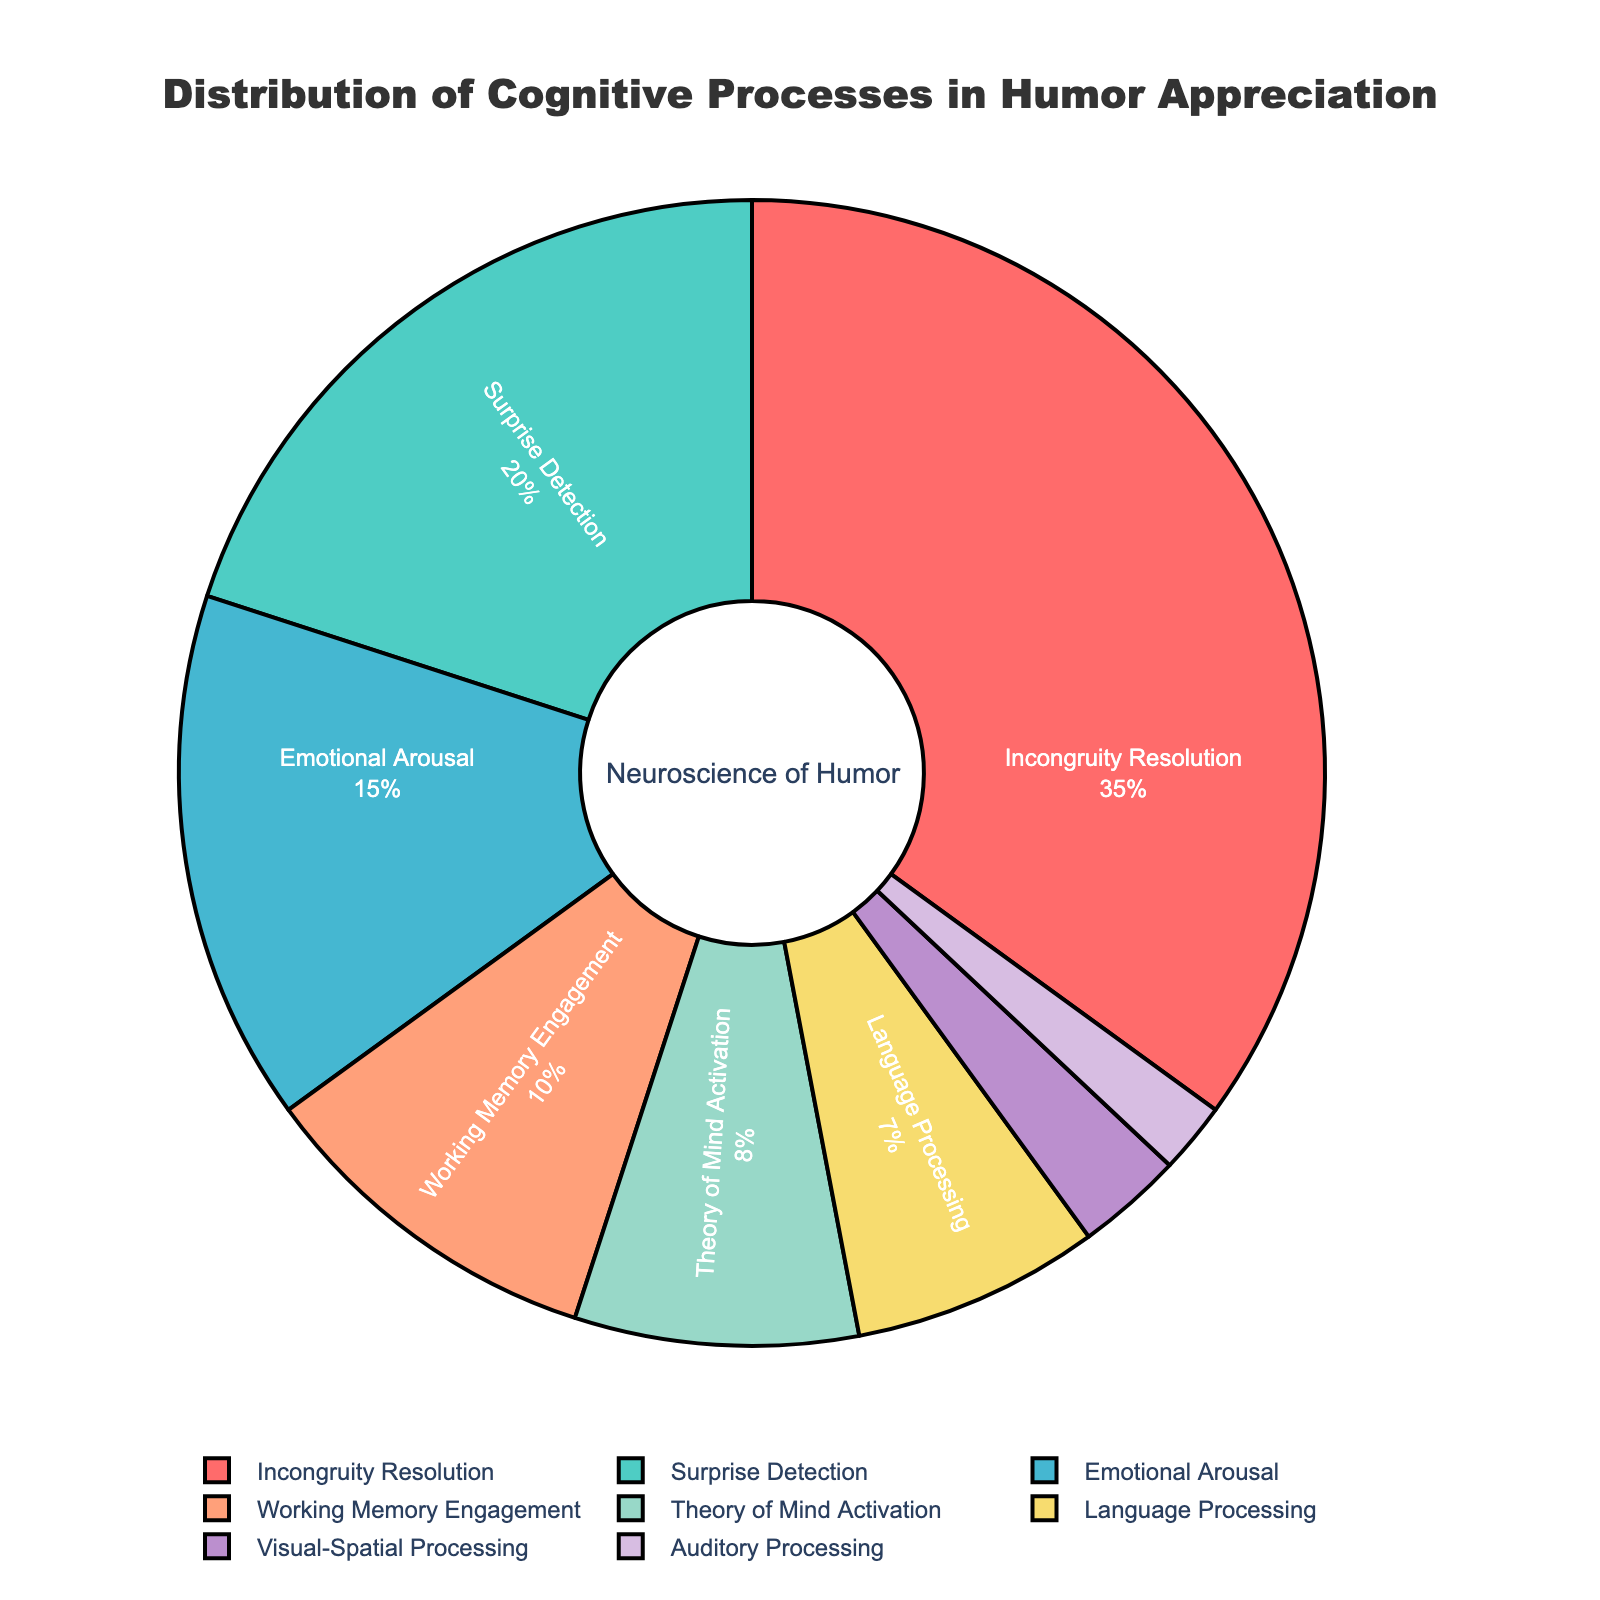What's the most prominent cognitive process involved in humor appreciation and its percentage? The figure indicates the cognitive processes and their corresponding percentages in humor appreciation. "Incongruity Resolution" has the largest slice associated with it.
Answer: Incongruity Resolution, 35% Which cognitive process has the smallest contribution and its percentage? The figure displays all cognitive processes and their percentages. "Auditory Processing" has the smallest contribution.
Answer: Auditory Processing, 2% What is the combined percentage of Theory of Mind Activation and Language Processing? The figure shows individual percentages for each cognitive process. Adding the percentages of "Theory of Mind Activation" (8%) and "Language Processing" (7%) gives the combined percentage.
Answer: 15% How much greater is the percentage of Incongruity Resolution compared to Visual-Spatial Processing? By looking at their respective slices, "Incongruity Resolution" has 35% and "Visual-Spatial Processing" has 3%. Subtracting the smaller from the larger gives the difference.
Answer: 32% Which two cognitive processes have equal or nearly equal contributions and what are their percentages? Analyzing the figure, "Theory of Mind Activation" has 8% and "Language Processing" has 7%, which are close in percentage.
Answer: Theory of Mind Activation, 8%; Language Processing, 7% What is the percentage contribution of cognitive processes that are less than 10% each? Cognitive processes under 10% include "Working Memory Engagement" (10%), "Theory of Mind Activation" (8%), "Language Processing" (7%), "Visual-Spatial Processing" (3%), and "Auditory Processing" (2%). Adding these gives the total contribution.
Answer: 30% What fraction of the pie chart does Working Memory Engagement represent? To convert the percentage of "Working Memory Engagement" (10%) into a fraction of the pie chart, we use: 10/100 = 1/10.
Answer: 1/10 Compare the contributions of Emotional Arousal and Surprise Detection. Which one is larger and by how much? Looking at the slices for "Emotional Arousal" (15%) and "Surprise Detection" (20%), it's clear "Surprise Detection" is larger. Subtracting the smaller from the larger gives the difference.
Answer: Surprise Detection is larger by 5% What is the total percentage contribution of the top three cognitive processes? Adding the percentages of "Incongruity Resolution" (35%), "Surprise Detection" (20%), and "Emotional Arousal" (15%) gives the total percentage.
Answer: 70% What would be the new percentage for Visual-Spatial Processing if its value doubled? Currently, "Visual-Spatial Processing" is 3%. Doubling its value gives 3% * 2 = 6%.
Answer: 6% 